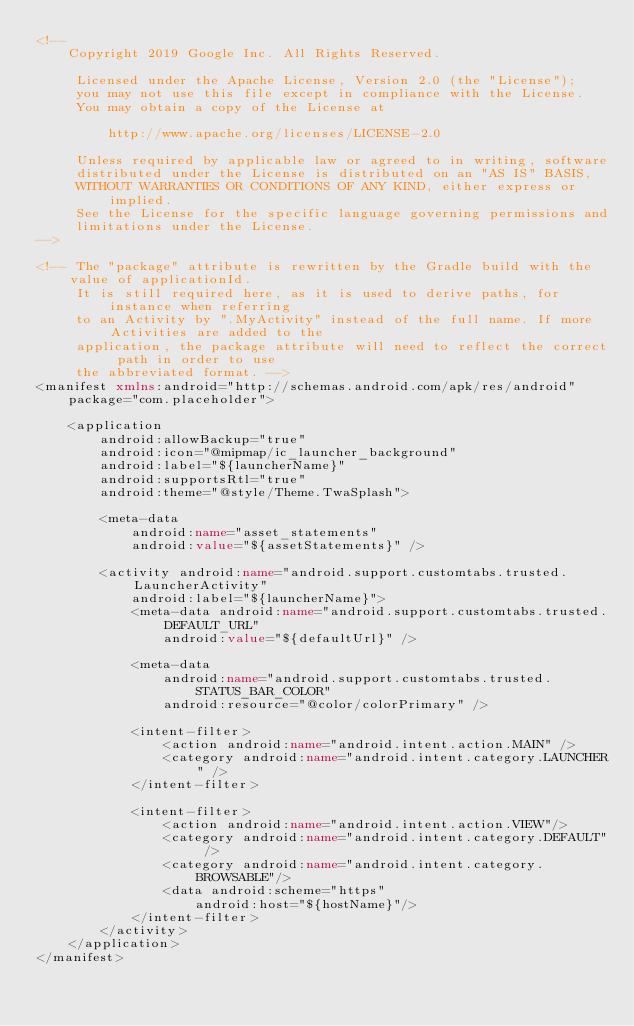Convert code to text. <code><loc_0><loc_0><loc_500><loc_500><_XML_><!--
    Copyright 2019 Google Inc. All Rights Reserved.

     Licensed under the Apache License, Version 2.0 (the "License");
     you may not use this file except in compliance with the License.
     You may obtain a copy of the License at

         http://www.apache.org/licenses/LICENSE-2.0

     Unless required by applicable law or agreed to in writing, software
     distributed under the License is distributed on an "AS IS" BASIS,
     WITHOUT WARRANTIES OR CONDITIONS OF ANY KIND, either express or implied.
     See the License for the specific language governing permissions and
     limitations under the License.
-->

<!-- The "package" attribute is rewritten by the Gradle build with the value of applicationId.
     It is still required here, as it is used to derive paths, for instance when referring
     to an Activity by ".MyActivity" instead of the full name. If more Activities are added to the
     application, the package attribute will need to reflect the correct path in order to use
     the abbreviated format. -->
<manifest xmlns:android="http://schemas.android.com/apk/res/android"
    package="com.placeholder">

    <application
        android:allowBackup="true"
        android:icon="@mipmap/ic_launcher_background"
        android:label="${launcherName}"
        android:supportsRtl="true"
        android:theme="@style/Theme.TwaSplash">

        <meta-data
            android:name="asset_statements"
            android:value="${assetStatements}" />

        <activity android:name="android.support.customtabs.trusted.LauncherActivity"
            android:label="${launcherName}">
            <meta-data android:name="android.support.customtabs.trusted.DEFAULT_URL"
                android:value="${defaultUrl}" />

            <meta-data
                android:name="android.support.customtabs.trusted.STATUS_BAR_COLOR"
                android:resource="@color/colorPrimary" />

            <intent-filter>
                <action android:name="android.intent.action.MAIN" />
                <category android:name="android.intent.category.LAUNCHER" />
            </intent-filter>

            <intent-filter>
                <action android:name="android.intent.action.VIEW"/>
                <category android:name="android.intent.category.DEFAULT" />
                <category android:name="android.intent.category.BROWSABLE"/>
                <data android:scheme="https"
                    android:host="${hostName}"/>
            </intent-filter>
        </activity>
    </application>
</manifest>
</code> 